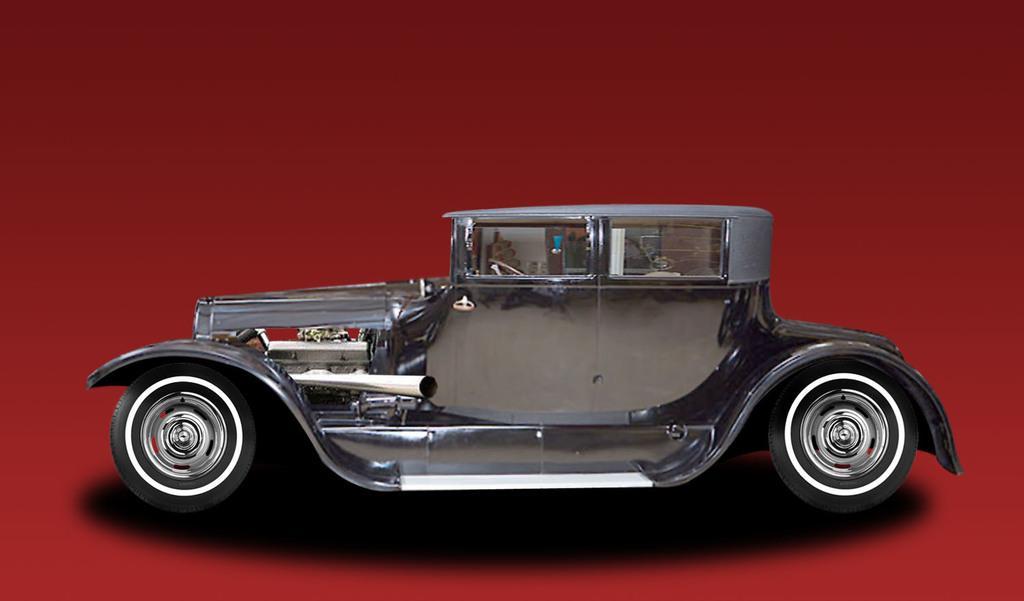Can you describe this image briefly? In this image I can see a car and a white color background. This image is taken may be in a hall. 